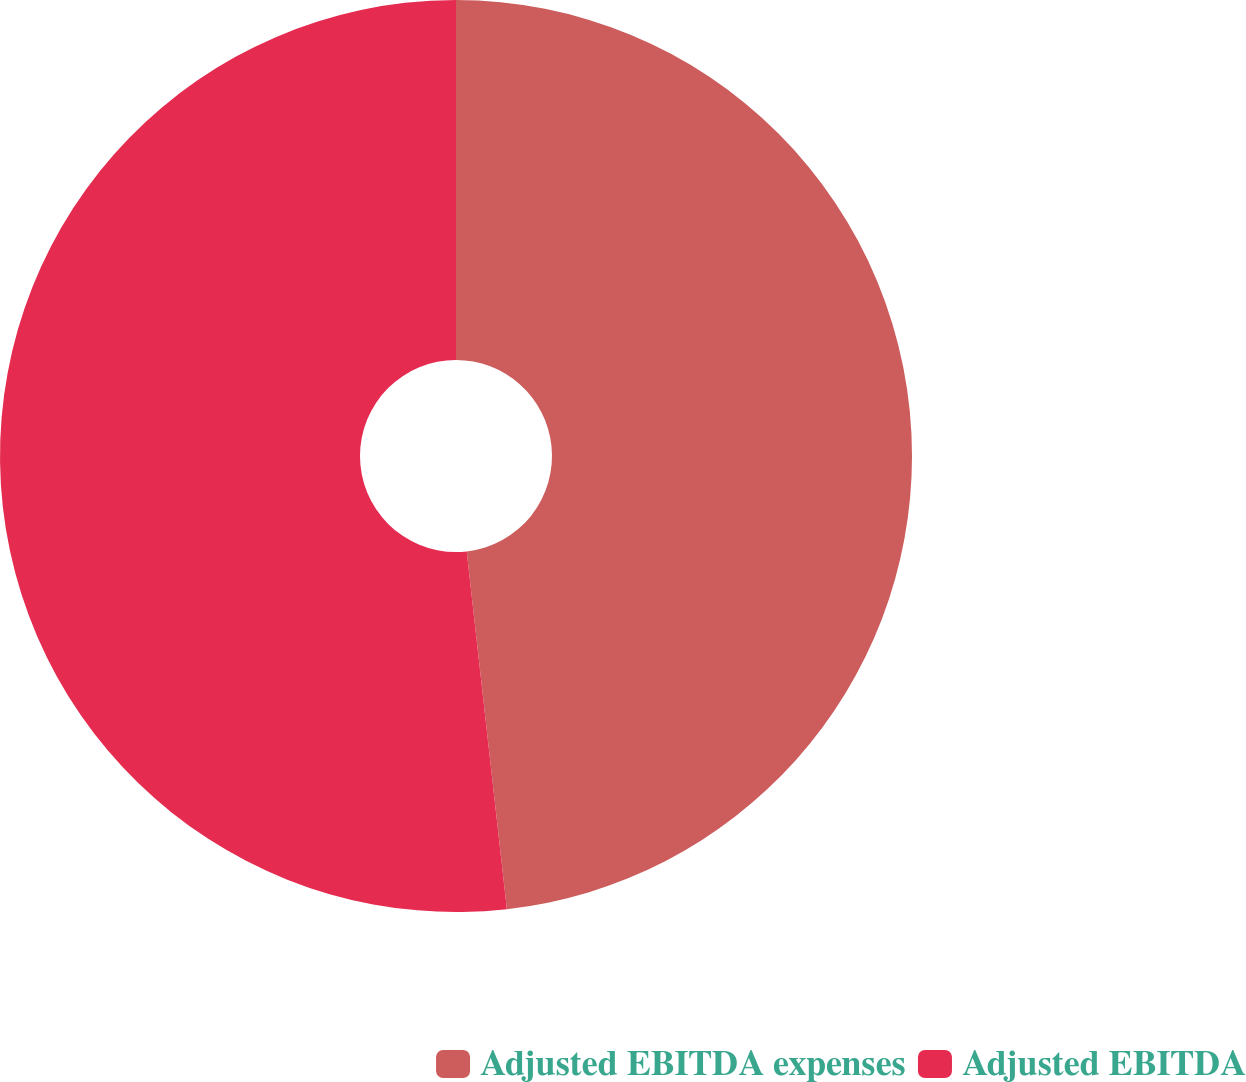Convert chart. <chart><loc_0><loc_0><loc_500><loc_500><pie_chart><fcel>Adjusted EBITDA expenses<fcel>Adjusted EBITDA<nl><fcel>48.22%<fcel>51.78%<nl></chart> 